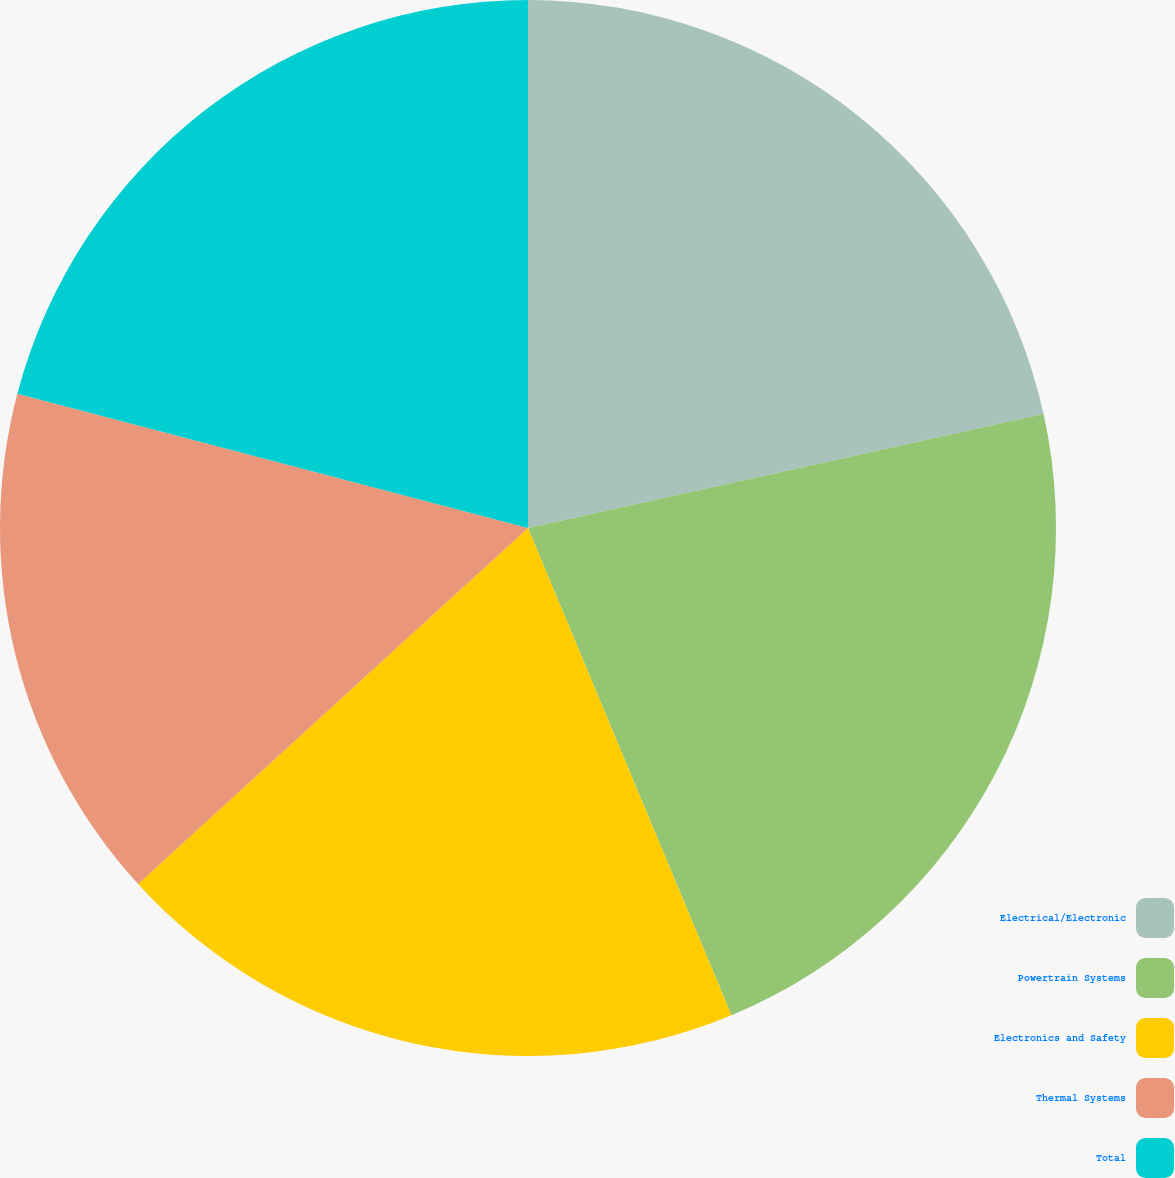Convert chart to OTSL. <chart><loc_0><loc_0><loc_500><loc_500><pie_chart><fcel>Electrical/Electronic<fcel>Powertrain Systems<fcel>Electronics and Safety<fcel>Thermal Systems<fcel>Total<nl><fcel>21.54%<fcel>22.17%<fcel>19.52%<fcel>15.87%<fcel>20.91%<nl></chart> 